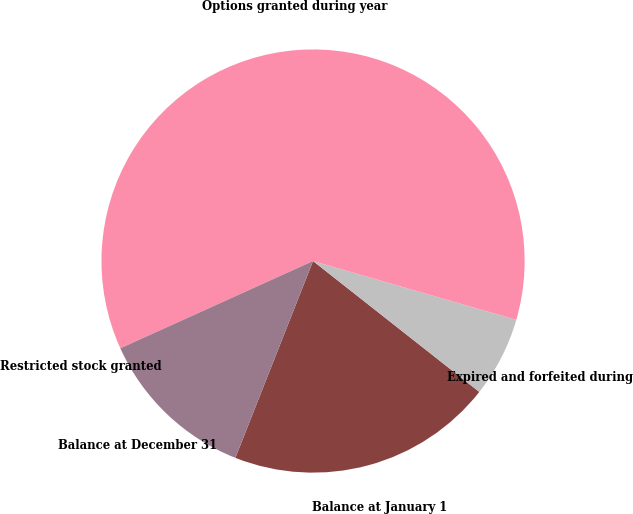<chart> <loc_0><loc_0><loc_500><loc_500><pie_chart><fcel>Balance at January 1<fcel>Expired and forfeited during<fcel>Options granted during year<fcel>Restricted stock granted<fcel>Balance at December 31<nl><fcel>20.37%<fcel>6.13%<fcel>61.25%<fcel>0.0%<fcel>12.25%<nl></chart> 